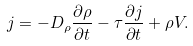Convert formula to latex. <formula><loc_0><loc_0><loc_500><loc_500>j = - D _ { \rho } \frac { \partial \rho } { \partial t } - \tau \frac { \partial j } { \partial t } + \rho V .</formula> 